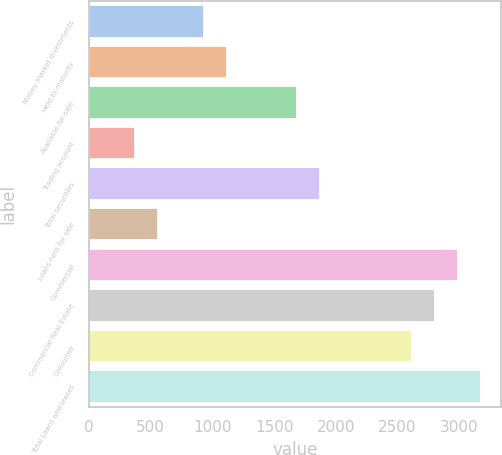<chart> <loc_0><loc_0><loc_500><loc_500><bar_chart><fcel>Money market investments<fcel>Held-to-maturity<fcel>Available-for-sale<fcel>Trading account<fcel>Total securities<fcel>Loans held for sale<fcel>Commercial<fcel>Commercial Real Estate<fcel>Consumer<fcel>Total Loans and leases<nl><fcel>934.75<fcel>1121.64<fcel>1682.31<fcel>374.08<fcel>1869.2<fcel>560.97<fcel>2990.54<fcel>2803.65<fcel>2616.76<fcel>3177.43<nl></chart> 